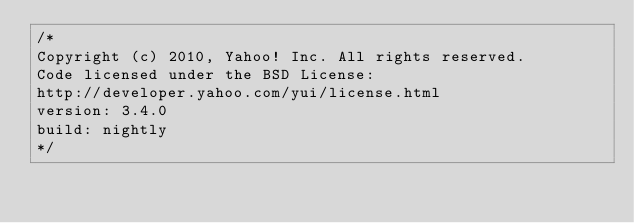Convert code to text. <code><loc_0><loc_0><loc_500><loc_500><_CSS_>/*
Copyright (c) 2010, Yahoo! Inc. All rights reserved.
Code licensed under the BSD License:
http://developer.yahoo.com/yui/license.html
version: 3.4.0
build: nightly
*/</code> 